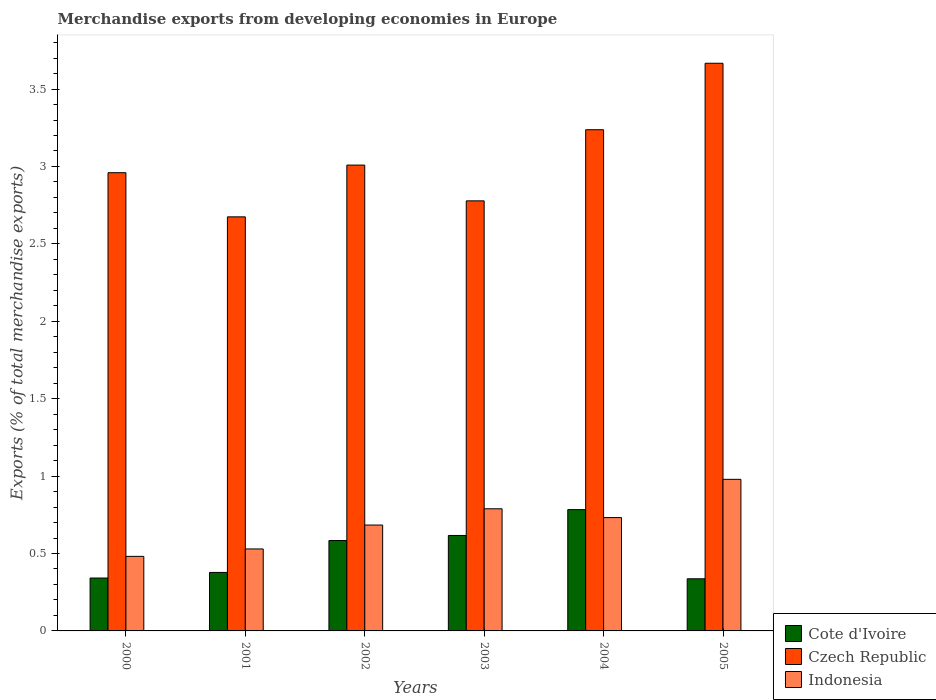How many different coloured bars are there?
Your response must be concise. 3. How many groups of bars are there?
Ensure brevity in your answer.  6. Are the number of bars per tick equal to the number of legend labels?
Keep it short and to the point. Yes. Are the number of bars on each tick of the X-axis equal?
Keep it short and to the point. Yes. How many bars are there on the 1st tick from the left?
Ensure brevity in your answer.  3. How many bars are there on the 2nd tick from the right?
Your answer should be very brief. 3. What is the percentage of total merchandise exports in Czech Republic in 2003?
Provide a succinct answer. 2.78. Across all years, what is the maximum percentage of total merchandise exports in Cote d'Ivoire?
Your response must be concise. 0.78. Across all years, what is the minimum percentage of total merchandise exports in Czech Republic?
Make the answer very short. 2.67. What is the total percentage of total merchandise exports in Cote d'Ivoire in the graph?
Give a very brief answer. 3.04. What is the difference between the percentage of total merchandise exports in Czech Republic in 2000 and that in 2001?
Offer a very short reply. 0.29. What is the difference between the percentage of total merchandise exports in Indonesia in 2002 and the percentage of total merchandise exports in Cote d'Ivoire in 2004?
Offer a very short reply. -0.1. What is the average percentage of total merchandise exports in Indonesia per year?
Provide a short and direct response. 0.7. In the year 2004, what is the difference between the percentage of total merchandise exports in Czech Republic and percentage of total merchandise exports in Indonesia?
Your response must be concise. 2.51. In how many years, is the percentage of total merchandise exports in Cote d'Ivoire greater than 0.5 %?
Keep it short and to the point. 3. What is the ratio of the percentage of total merchandise exports in Cote d'Ivoire in 2000 to that in 2002?
Provide a succinct answer. 0.59. Is the percentage of total merchandise exports in Cote d'Ivoire in 2000 less than that in 2001?
Make the answer very short. Yes. What is the difference between the highest and the second highest percentage of total merchandise exports in Indonesia?
Provide a succinct answer. 0.19. What is the difference between the highest and the lowest percentage of total merchandise exports in Indonesia?
Your response must be concise. 0.5. In how many years, is the percentage of total merchandise exports in Indonesia greater than the average percentage of total merchandise exports in Indonesia taken over all years?
Make the answer very short. 3. What does the 2nd bar from the left in 2005 represents?
Offer a very short reply. Czech Republic. What does the 3rd bar from the right in 2000 represents?
Offer a very short reply. Cote d'Ivoire. Is it the case that in every year, the sum of the percentage of total merchandise exports in Indonesia and percentage of total merchandise exports in Cote d'Ivoire is greater than the percentage of total merchandise exports in Czech Republic?
Offer a very short reply. No. Are all the bars in the graph horizontal?
Your answer should be very brief. No. What is the difference between two consecutive major ticks on the Y-axis?
Your answer should be very brief. 0.5. How many legend labels are there?
Offer a terse response. 3. How are the legend labels stacked?
Keep it short and to the point. Vertical. What is the title of the graph?
Your response must be concise. Merchandise exports from developing economies in Europe. What is the label or title of the Y-axis?
Provide a short and direct response. Exports (% of total merchandise exports). What is the Exports (% of total merchandise exports) of Cote d'Ivoire in 2000?
Provide a succinct answer. 0.34. What is the Exports (% of total merchandise exports) in Czech Republic in 2000?
Your answer should be very brief. 2.96. What is the Exports (% of total merchandise exports) in Indonesia in 2000?
Provide a succinct answer. 0.48. What is the Exports (% of total merchandise exports) in Cote d'Ivoire in 2001?
Your answer should be compact. 0.38. What is the Exports (% of total merchandise exports) of Czech Republic in 2001?
Provide a succinct answer. 2.67. What is the Exports (% of total merchandise exports) in Indonesia in 2001?
Provide a succinct answer. 0.53. What is the Exports (% of total merchandise exports) of Cote d'Ivoire in 2002?
Offer a very short reply. 0.58. What is the Exports (% of total merchandise exports) of Czech Republic in 2002?
Your answer should be very brief. 3.01. What is the Exports (% of total merchandise exports) of Indonesia in 2002?
Keep it short and to the point. 0.68. What is the Exports (% of total merchandise exports) in Cote d'Ivoire in 2003?
Give a very brief answer. 0.62. What is the Exports (% of total merchandise exports) of Czech Republic in 2003?
Provide a succinct answer. 2.78. What is the Exports (% of total merchandise exports) of Indonesia in 2003?
Your response must be concise. 0.79. What is the Exports (% of total merchandise exports) of Cote d'Ivoire in 2004?
Keep it short and to the point. 0.78. What is the Exports (% of total merchandise exports) of Czech Republic in 2004?
Your answer should be compact. 3.24. What is the Exports (% of total merchandise exports) in Indonesia in 2004?
Your answer should be compact. 0.73. What is the Exports (% of total merchandise exports) of Cote d'Ivoire in 2005?
Your answer should be compact. 0.34. What is the Exports (% of total merchandise exports) in Czech Republic in 2005?
Keep it short and to the point. 3.67. What is the Exports (% of total merchandise exports) in Indonesia in 2005?
Your answer should be very brief. 0.98. Across all years, what is the maximum Exports (% of total merchandise exports) in Cote d'Ivoire?
Your answer should be compact. 0.78. Across all years, what is the maximum Exports (% of total merchandise exports) in Czech Republic?
Offer a very short reply. 3.67. Across all years, what is the maximum Exports (% of total merchandise exports) in Indonesia?
Provide a short and direct response. 0.98. Across all years, what is the minimum Exports (% of total merchandise exports) in Cote d'Ivoire?
Provide a succinct answer. 0.34. Across all years, what is the minimum Exports (% of total merchandise exports) in Czech Republic?
Your response must be concise. 2.67. Across all years, what is the minimum Exports (% of total merchandise exports) of Indonesia?
Offer a very short reply. 0.48. What is the total Exports (% of total merchandise exports) of Cote d'Ivoire in the graph?
Give a very brief answer. 3.04. What is the total Exports (% of total merchandise exports) in Czech Republic in the graph?
Your answer should be very brief. 18.32. What is the total Exports (% of total merchandise exports) in Indonesia in the graph?
Ensure brevity in your answer.  4.2. What is the difference between the Exports (% of total merchandise exports) of Cote d'Ivoire in 2000 and that in 2001?
Offer a terse response. -0.04. What is the difference between the Exports (% of total merchandise exports) in Czech Republic in 2000 and that in 2001?
Give a very brief answer. 0.29. What is the difference between the Exports (% of total merchandise exports) of Indonesia in 2000 and that in 2001?
Keep it short and to the point. -0.05. What is the difference between the Exports (% of total merchandise exports) in Cote d'Ivoire in 2000 and that in 2002?
Make the answer very short. -0.24. What is the difference between the Exports (% of total merchandise exports) in Czech Republic in 2000 and that in 2002?
Provide a succinct answer. -0.05. What is the difference between the Exports (% of total merchandise exports) in Indonesia in 2000 and that in 2002?
Your response must be concise. -0.2. What is the difference between the Exports (% of total merchandise exports) of Cote d'Ivoire in 2000 and that in 2003?
Give a very brief answer. -0.27. What is the difference between the Exports (% of total merchandise exports) in Czech Republic in 2000 and that in 2003?
Offer a terse response. 0.18. What is the difference between the Exports (% of total merchandise exports) of Indonesia in 2000 and that in 2003?
Ensure brevity in your answer.  -0.31. What is the difference between the Exports (% of total merchandise exports) of Cote d'Ivoire in 2000 and that in 2004?
Ensure brevity in your answer.  -0.44. What is the difference between the Exports (% of total merchandise exports) of Czech Republic in 2000 and that in 2004?
Ensure brevity in your answer.  -0.28. What is the difference between the Exports (% of total merchandise exports) of Indonesia in 2000 and that in 2004?
Give a very brief answer. -0.25. What is the difference between the Exports (% of total merchandise exports) in Cote d'Ivoire in 2000 and that in 2005?
Provide a succinct answer. 0.01. What is the difference between the Exports (% of total merchandise exports) in Czech Republic in 2000 and that in 2005?
Your answer should be very brief. -0.71. What is the difference between the Exports (% of total merchandise exports) in Indonesia in 2000 and that in 2005?
Offer a very short reply. -0.5. What is the difference between the Exports (% of total merchandise exports) in Cote d'Ivoire in 2001 and that in 2002?
Give a very brief answer. -0.21. What is the difference between the Exports (% of total merchandise exports) of Czech Republic in 2001 and that in 2002?
Your answer should be compact. -0.33. What is the difference between the Exports (% of total merchandise exports) of Indonesia in 2001 and that in 2002?
Your answer should be very brief. -0.15. What is the difference between the Exports (% of total merchandise exports) of Cote d'Ivoire in 2001 and that in 2003?
Your answer should be compact. -0.24. What is the difference between the Exports (% of total merchandise exports) of Czech Republic in 2001 and that in 2003?
Provide a succinct answer. -0.1. What is the difference between the Exports (% of total merchandise exports) of Indonesia in 2001 and that in 2003?
Ensure brevity in your answer.  -0.26. What is the difference between the Exports (% of total merchandise exports) of Cote d'Ivoire in 2001 and that in 2004?
Your response must be concise. -0.41. What is the difference between the Exports (% of total merchandise exports) of Czech Republic in 2001 and that in 2004?
Offer a terse response. -0.56. What is the difference between the Exports (% of total merchandise exports) in Indonesia in 2001 and that in 2004?
Make the answer very short. -0.2. What is the difference between the Exports (% of total merchandise exports) of Cote d'Ivoire in 2001 and that in 2005?
Give a very brief answer. 0.04. What is the difference between the Exports (% of total merchandise exports) of Czech Republic in 2001 and that in 2005?
Your answer should be compact. -0.99. What is the difference between the Exports (% of total merchandise exports) of Indonesia in 2001 and that in 2005?
Your answer should be compact. -0.45. What is the difference between the Exports (% of total merchandise exports) of Cote d'Ivoire in 2002 and that in 2003?
Your answer should be very brief. -0.03. What is the difference between the Exports (% of total merchandise exports) of Czech Republic in 2002 and that in 2003?
Your answer should be compact. 0.23. What is the difference between the Exports (% of total merchandise exports) of Indonesia in 2002 and that in 2003?
Provide a short and direct response. -0.1. What is the difference between the Exports (% of total merchandise exports) of Cote d'Ivoire in 2002 and that in 2004?
Provide a succinct answer. -0.2. What is the difference between the Exports (% of total merchandise exports) of Czech Republic in 2002 and that in 2004?
Ensure brevity in your answer.  -0.23. What is the difference between the Exports (% of total merchandise exports) in Indonesia in 2002 and that in 2004?
Make the answer very short. -0.05. What is the difference between the Exports (% of total merchandise exports) in Cote d'Ivoire in 2002 and that in 2005?
Your answer should be very brief. 0.25. What is the difference between the Exports (% of total merchandise exports) in Czech Republic in 2002 and that in 2005?
Offer a terse response. -0.66. What is the difference between the Exports (% of total merchandise exports) of Indonesia in 2002 and that in 2005?
Make the answer very short. -0.3. What is the difference between the Exports (% of total merchandise exports) in Cote d'Ivoire in 2003 and that in 2004?
Your answer should be compact. -0.17. What is the difference between the Exports (% of total merchandise exports) of Czech Republic in 2003 and that in 2004?
Ensure brevity in your answer.  -0.46. What is the difference between the Exports (% of total merchandise exports) in Indonesia in 2003 and that in 2004?
Offer a terse response. 0.06. What is the difference between the Exports (% of total merchandise exports) of Cote d'Ivoire in 2003 and that in 2005?
Offer a very short reply. 0.28. What is the difference between the Exports (% of total merchandise exports) in Czech Republic in 2003 and that in 2005?
Offer a terse response. -0.89. What is the difference between the Exports (% of total merchandise exports) of Indonesia in 2003 and that in 2005?
Provide a succinct answer. -0.19. What is the difference between the Exports (% of total merchandise exports) of Cote d'Ivoire in 2004 and that in 2005?
Offer a very short reply. 0.45. What is the difference between the Exports (% of total merchandise exports) in Czech Republic in 2004 and that in 2005?
Provide a short and direct response. -0.43. What is the difference between the Exports (% of total merchandise exports) of Indonesia in 2004 and that in 2005?
Your answer should be compact. -0.25. What is the difference between the Exports (% of total merchandise exports) in Cote d'Ivoire in 2000 and the Exports (% of total merchandise exports) in Czech Republic in 2001?
Offer a terse response. -2.33. What is the difference between the Exports (% of total merchandise exports) of Cote d'Ivoire in 2000 and the Exports (% of total merchandise exports) of Indonesia in 2001?
Provide a short and direct response. -0.19. What is the difference between the Exports (% of total merchandise exports) of Czech Republic in 2000 and the Exports (% of total merchandise exports) of Indonesia in 2001?
Give a very brief answer. 2.43. What is the difference between the Exports (% of total merchandise exports) of Cote d'Ivoire in 2000 and the Exports (% of total merchandise exports) of Czech Republic in 2002?
Make the answer very short. -2.67. What is the difference between the Exports (% of total merchandise exports) of Cote d'Ivoire in 2000 and the Exports (% of total merchandise exports) of Indonesia in 2002?
Provide a succinct answer. -0.34. What is the difference between the Exports (% of total merchandise exports) in Czech Republic in 2000 and the Exports (% of total merchandise exports) in Indonesia in 2002?
Your answer should be compact. 2.28. What is the difference between the Exports (% of total merchandise exports) in Cote d'Ivoire in 2000 and the Exports (% of total merchandise exports) in Czech Republic in 2003?
Your answer should be very brief. -2.44. What is the difference between the Exports (% of total merchandise exports) in Cote d'Ivoire in 2000 and the Exports (% of total merchandise exports) in Indonesia in 2003?
Ensure brevity in your answer.  -0.45. What is the difference between the Exports (% of total merchandise exports) in Czech Republic in 2000 and the Exports (% of total merchandise exports) in Indonesia in 2003?
Make the answer very short. 2.17. What is the difference between the Exports (% of total merchandise exports) of Cote d'Ivoire in 2000 and the Exports (% of total merchandise exports) of Czech Republic in 2004?
Your response must be concise. -2.9. What is the difference between the Exports (% of total merchandise exports) of Cote d'Ivoire in 2000 and the Exports (% of total merchandise exports) of Indonesia in 2004?
Your answer should be very brief. -0.39. What is the difference between the Exports (% of total merchandise exports) of Czech Republic in 2000 and the Exports (% of total merchandise exports) of Indonesia in 2004?
Provide a short and direct response. 2.23. What is the difference between the Exports (% of total merchandise exports) in Cote d'Ivoire in 2000 and the Exports (% of total merchandise exports) in Czech Republic in 2005?
Keep it short and to the point. -3.32. What is the difference between the Exports (% of total merchandise exports) of Cote d'Ivoire in 2000 and the Exports (% of total merchandise exports) of Indonesia in 2005?
Your answer should be compact. -0.64. What is the difference between the Exports (% of total merchandise exports) of Czech Republic in 2000 and the Exports (% of total merchandise exports) of Indonesia in 2005?
Provide a succinct answer. 1.98. What is the difference between the Exports (% of total merchandise exports) of Cote d'Ivoire in 2001 and the Exports (% of total merchandise exports) of Czech Republic in 2002?
Offer a terse response. -2.63. What is the difference between the Exports (% of total merchandise exports) in Cote d'Ivoire in 2001 and the Exports (% of total merchandise exports) in Indonesia in 2002?
Your answer should be compact. -0.31. What is the difference between the Exports (% of total merchandise exports) in Czech Republic in 2001 and the Exports (% of total merchandise exports) in Indonesia in 2002?
Make the answer very short. 1.99. What is the difference between the Exports (% of total merchandise exports) of Cote d'Ivoire in 2001 and the Exports (% of total merchandise exports) of Czech Republic in 2003?
Give a very brief answer. -2.4. What is the difference between the Exports (% of total merchandise exports) in Cote d'Ivoire in 2001 and the Exports (% of total merchandise exports) in Indonesia in 2003?
Provide a short and direct response. -0.41. What is the difference between the Exports (% of total merchandise exports) of Czech Republic in 2001 and the Exports (% of total merchandise exports) of Indonesia in 2003?
Give a very brief answer. 1.89. What is the difference between the Exports (% of total merchandise exports) of Cote d'Ivoire in 2001 and the Exports (% of total merchandise exports) of Czech Republic in 2004?
Ensure brevity in your answer.  -2.86. What is the difference between the Exports (% of total merchandise exports) of Cote d'Ivoire in 2001 and the Exports (% of total merchandise exports) of Indonesia in 2004?
Offer a terse response. -0.35. What is the difference between the Exports (% of total merchandise exports) in Czech Republic in 2001 and the Exports (% of total merchandise exports) in Indonesia in 2004?
Offer a very short reply. 1.94. What is the difference between the Exports (% of total merchandise exports) of Cote d'Ivoire in 2001 and the Exports (% of total merchandise exports) of Czech Republic in 2005?
Your answer should be compact. -3.29. What is the difference between the Exports (% of total merchandise exports) in Cote d'Ivoire in 2001 and the Exports (% of total merchandise exports) in Indonesia in 2005?
Keep it short and to the point. -0.6. What is the difference between the Exports (% of total merchandise exports) of Czech Republic in 2001 and the Exports (% of total merchandise exports) of Indonesia in 2005?
Your response must be concise. 1.7. What is the difference between the Exports (% of total merchandise exports) in Cote d'Ivoire in 2002 and the Exports (% of total merchandise exports) in Czech Republic in 2003?
Offer a terse response. -2.19. What is the difference between the Exports (% of total merchandise exports) of Cote d'Ivoire in 2002 and the Exports (% of total merchandise exports) of Indonesia in 2003?
Give a very brief answer. -0.2. What is the difference between the Exports (% of total merchandise exports) in Czech Republic in 2002 and the Exports (% of total merchandise exports) in Indonesia in 2003?
Make the answer very short. 2.22. What is the difference between the Exports (% of total merchandise exports) in Cote d'Ivoire in 2002 and the Exports (% of total merchandise exports) in Czech Republic in 2004?
Keep it short and to the point. -2.65. What is the difference between the Exports (% of total merchandise exports) in Cote d'Ivoire in 2002 and the Exports (% of total merchandise exports) in Indonesia in 2004?
Offer a very short reply. -0.15. What is the difference between the Exports (% of total merchandise exports) in Czech Republic in 2002 and the Exports (% of total merchandise exports) in Indonesia in 2004?
Make the answer very short. 2.28. What is the difference between the Exports (% of total merchandise exports) of Cote d'Ivoire in 2002 and the Exports (% of total merchandise exports) of Czech Republic in 2005?
Provide a short and direct response. -3.08. What is the difference between the Exports (% of total merchandise exports) of Cote d'Ivoire in 2002 and the Exports (% of total merchandise exports) of Indonesia in 2005?
Keep it short and to the point. -0.4. What is the difference between the Exports (% of total merchandise exports) of Czech Republic in 2002 and the Exports (% of total merchandise exports) of Indonesia in 2005?
Keep it short and to the point. 2.03. What is the difference between the Exports (% of total merchandise exports) of Cote d'Ivoire in 2003 and the Exports (% of total merchandise exports) of Czech Republic in 2004?
Your response must be concise. -2.62. What is the difference between the Exports (% of total merchandise exports) in Cote d'Ivoire in 2003 and the Exports (% of total merchandise exports) in Indonesia in 2004?
Give a very brief answer. -0.12. What is the difference between the Exports (% of total merchandise exports) in Czech Republic in 2003 and the Exports (% of total merchandise exports) in Indonesia in 2004?
Keep it short and to the point. 2.05. What is the difference between the Exports (% of total merchandise exports) of Cote d'Ivoire in 2003 and the Exports (% of total merchandise exports) of Czech Republic in 2005?
Keep it short and to the point. -3.05. What is the difference between the Exports (% of total merchandise exports) in Cote d'Ivoire in 2003 and the Exports (% of total merchandise exports) in Indonesia in 2005?
Offer a very short reply. -0.36. What is the difference between the Exports (% of total merchandise exports) of Czech Republic in 2003 and the Exports (% of total merchandise exports) of Indonesia in 2005?
Your answer should be very brief. 1.8. What is the difference between the Exports (% of total merchandise exports) in Cote d'Ivoire in 2004 and the Exports (% of total merchandise exports) in Czech Republic in 2005?
Provide a succinct answer. -2.88. What is the difference between the Exports (% of total merchandise exports) in Cote d'Ivoire in 2004 and the Exports (% of total merchandise exports) in Indonesia in 2005?
Provide a short and direct response. -0.2. What is the difference between the Exports (% of total merchandise exports) of Czech Republic in 2004 and the Exports (% of total merchandise exports) of Indonesia in 2005?
Offer a terse response. 2.26. What is the average Exports (% of total merchandise exports) in Cote d'Ivoire per year?
Your answer should be very brief. 0.51. What is the average Exports (% of total merchandise exports) in Czech Republic per year?
Your response must be concise. 3.05. What is the average Exports (% of total merchandise exports) in Indonesia per year?
Your answer should be very brief. 0.7. In the year 2000, what is the difference between the Exports (% of total merchandise exports) in Cote d'Ivoire and Exports (% of total merchandise exports) in Czech Republic?
Provide a short and direct response. -2.62. In the year 2000, what is the difference between the Exports (% of total merchandise exports) in Cote d'Ivoire and Exports (% of total merchandise exports) in Indonesia?
Offer a very short reply. -0.14. In the year 2000, what is the difference between the Exports (% of total merchandise exports) in Czech Republic and Exports (% of total merchandise exports) in Indonesia?
Ensure brevity in your answer.  2.48. In the year 2001, what is the difference between the Exports (% of total merchandise exports) in Cote d'Ivoire and Exports (% of total merchandise exports) in Czech Republic?
Ensure brevity in your answer.  -2.3. In the year 2001, what is the difference between the Exports (% of total merchandise exports) in Cote d'Ivoire and Exports (% of total merchandise exports) in Indonesia?
Offer a terse response. -0.15. In the year 2001, what is the difference between the Exports (% of total merchandise exports) in Czech Republic and Exports (% of total merchandise exports) in Indonesia?
Provide a succinct answer. 2.15. In the year 2002, what is the difference between the Exports (% of total merchandise exports) in Cote d'Ivoire and Exports (% of total merchandise exports) in Czech Republic?
Keep it short and to the point. -2.42. In the year 2002, what is the difference between the Exports (% of total merchandise exports) in Cote d'Ivoire and Exports (% of total merchandise exports) in Indonesia?
Provide a short and direct response. -0.1. In the year 2002, what is the difference between the Exports (% of total merchandise exports) of Czech Republic and Exports (% of total merchandise exports) of Indonesia?
Offer a terse response. 2.33. In the year 2003, what is the difference between the Exports (% of total merchandise exports) in Cote d'Ivoire and Exports (% of total merchandise exports) in Czech Republic?
Your response must be concise. -2.16. In the year 2003, what is the difference between the Exports (% of total merchandise exports) in Cote d'Ivoire and Exports (% of total merchandise exports) in Indonesia?
Your response must be concise. -0.17. In the year 2003, what is the difference between the Exports (% of total merchandise exports) in Czech Republic and Exports (% of total merchandise exports) in Indonesia?
Ensure brevity in your answer.  1.99. In the year 2004, what is the difference between the Exports (% of total merchandise exports) in Cote d'Ivoire and Exports (% of total merchandise exports) in Czech Republic?
Offer a very short reply. -2.45. In the year 2004, what is the difference between the Exports (% of total merchandise exports) in Cote d'Ivoire and Exports (% of total merchandise exports) in Indonesia?
Your answer should be very brief. 0.05. In the year 2004, what is the difference between the Exports (% of total merchandise exports) of Czech Republic and Exports (% of total merchandise exports) of Indonesia?
Provide a short and direct response. 2.51. In the year 2005, what is the difference between the Exports (% of total merchandise exports) of Cote d'Ivoire and Exports (% of total merchandise exports) of Czech Republic?
Ensure brevity in your answer.  -3.33. In the year 2005, what is the difference between the Exports (% of total merchandise exports) of Cote d'Ivoire and Exports (% of total merchandise exports) of Indonesia?
Your answer should be very brief. -0.64. In the year 2005, what is the difference between the Exports (% of total merchandise exports) of Czech Republic and Exports (% of total merchandise exports) of Indonesia?
Ensure brevity in your answer.  2.69. What is the ratio of the Exports (% of total merchandise exports) in Cote d'Ivoire in 2000 to that in 2001?
Offer a very short reply. 0.9. What is the ratio of the Exports (% of total merchandise exports) in Czech Republic in 2000 to that in 2001?
Give a very brief answer. 1.11. What is the ratio of the Exports (% of total merchandise exports) in Indonesia in 2000 to that in 2001?
Make the answer very short. 0.91. What is the ratio of the Exports (% of total merchandise exports) of Cote d'Ivoire in 2000 to that in 2002?
Ensure brevity in your answer.  0.59. What is the ratio of the Exports (% of total merchandise exports) in Czech Republic in 2000 to that in 2002?
Offer a very short reply. 0.98. What is the ratio of the Exports (% of total merchandise exports) of Indonesia in 2000 to that in 2002?
Offer a terse response. 0.7. What is the ratio of the Exports (% of total merchandise exports) in Cote d'Ivoire in 2000 to that in 2003?
Your answer should be very brief. 0.55. What is the ratio of the Exports (% of total merchandise exports) in Czech Republic in 2000 to that in 2003?
Make the answer very short. 1.07. What is the ratio of the Exports (% of total merchandise exports) in Indonesia in 2000 to that in 2003?
Keep it short and to the point. 0.61. What is the ratio of the Exports (% of total merchandise exports) in Cote d'Ivoire in 2000 to that in 2004?
Give a very brief answer. 0.44. What is the ratio of the Exports (% of total merchandise exports) in Czech Republic in 2000 to that in 2004?
Your response must be concise. 0.91. What is the ratio of the Exports (% of total merchandise exports) of Indonesia in 2000 to that in 2004?
Your answer should be compact. 0.66. What is the ratio of the Exports (% of total merchandise exports) of Cote d'Ivoire in 2000 to that in 2005?
Provide a short and direct response. 1.01. What is the ratio of the Exports (% of total merchandise exports) of Czech Republic in 2000 to that in 2005?
Provide a succinct answer. 0.81. What is the ratio of the Exports (% of total merchandise exports) of Indonesia in 2000 to that in 2005?
Provide a succinct answer. 0.49. What is the ratio of the Exports (% of total merchandise exports) of Cote d'Ivoire in 2001 to that in 2002?
Offer a very short reply. 0.65. What is the ratio of the Exports (% of total merchandise exports) in Indonesia in 2001 to that in 2002?
Your answer should be compact. 0.77. What is the ratio of the Exports (% of total merchandise exports) of Cote d'Ivoire in 2001 to that in 2003?
Your response must be concise. 0.61. What is the ratio of the Exports (% of total merchandise exports) in Czech Republic in 2001 to that in 2003?
Your response must be concise. 0.96. What is the ratio of the Exports (% of total merchandise exports) of Indonesia in 2001 to that in 2003?
Provide a short and direct response. 0.67. What is the ratio of the Exports (% of total merchandise exports) in Cote d'Ivoire in 2001 to that in 2004?
Offer a terse response. 0.48. What is the ratio of the Exports (% of total merchandise exports) of Czech Republic in 2001 to that in 2004?
Offer a terse response. 0.83. What is the ratio of the Exports (% of total merchandise exports) of Indonesia in 2001 to that in 2004?
Provide a succinct answer. 0.72. What is the ratio of the Exports (% of total merchandise exports) in Cote d'Ivoire in 2001 to that in 2005?
Make the answer very short. 1.12. What is the ratio of the Exports (% of total merchandise exports) of Czech Republic in 2001 to that in 2005?
Offer a terse response. 0.73. What is the ratio of the Exports (% of total merchandise exports) of Indonesia in 2001 to that in 2005?
Your answer should be compact. 0.54. What is the ratio of the Exports (% of total merchandise exports) of Cote d'Ivoire in 2002 to that in 2003?
Offer a terse response. 0.95. What is the ratio of the Exports (% of total merchandise exports) in Czech Republic in 2002 to that in 2003?
Your answer should be compact. 1.08. What is the ratio of the Exports (% of total merchandise exports) in Indonesia in 2002 to that in 2003?
Your answer should be very brief. 0.87. What is the ratio of the Exports (% of total merchandise exports) in Cote d'Ivoire in 2002 to that in 2004?
Offer a very short reply. 0.75. What is the ratio of the Exports (% of total merchandise exports) of Czech Republic in 2002 to that in 2004?
Provide a succinct answer. 0.93. What is the ratio of the Exports (% of total merchandise exports) of Indonesia in 2002 to that in 2004?
Your answer should be very brief. 0.93. What is the ratio of the Exports (% of total merchandise exports) in Cote d'Ivoire in 2002 to that in 2005?
Ensure brevity in your answer.  1.73. What is the ratio of the Exports (% of total merchandise exports) in Czech Republic in 2002 to that in 2005?
Ensure brevity in your answer.  0.82. What is the ratio of the Exports (% of total merchandise exports) in Indonesia in 2002 to that in 2005?
Give a very brief answer. 0.7. What is the ratio of the Exports (% of total merchandise exports) in Cote d'Ivoire in 2003 to that in 2004?
Provide a short and direct response. 0.79. What is the ratio of the Exports (% of total merchandise exports) of Czech Republic in 2003 to that in 2004?
Your response must be concise. 0.86. What is the ratio of the Exports (% of total merchandise exports) in Indonesia in 2003 to that in 2004?
Your response must be concise. 1.08. What is the ratio of the Exports (% of total merchandise exports) in Cote d'Ivoire in 2003 to that in 2005?
Give a very brief answer. 1.83. What is the ratio of the Exports (% of total merchandise exports) of Czech Republic in 2003 to that in 2005?
Make the answer very short. 0.76. What is the ratio of the Exports (% of total merchandise exports) of Indonesia in 2003 to that in 2005?
Your answer should be very brief. 0.81. What is the ratio of the Exports (% of total merchandise exports) of Cote d'Ivoire in 2004 to that in 2005?
Your answer should be compact. 2.33. What is the ratio of the Exports (% of total merchandise exports) of Czech Republic in 2004 to that in 2005?
Your answer should be very brief. 0.88. What is the ratio of the Exports (% of total merchandise exports) in Indonesia in 2004 to that in 2005?
Give a very brief answer. 0.75. What is the difference between the highest and the second highest Exports (% of total merchandise exports) in Cote d'Ivoire?
Make the answer very short. 0.17. What is the difference between the highest and the second highest Exports (% of total merchandise exports) of Czech Republic?
Your response must be concise. 0.43. What is the difference between the highest and the second highest Exports (% of total merchandise exports) of Indonesia?
Your answer should be compact. 0.19. What is the difference between the highest and the lowest Exports (% of total merchandise exports) of Cote d'Ivoire?
Ensure brevity in your answer.  0.45. What is the difference between the highest and the lowest Exports (% of total merchandise exports) of Indonesia?
Your response must be concise. 0.5. 